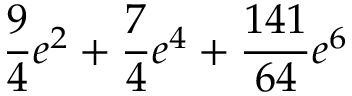Convert formula to latex. <formula><loc_0><loc_0><loc_500><loc_500>\frac { 9 } { 4 } e ^ { 2 } + \frac { 7 } { 4 } e ^ { 4 } + \frac { 1 4 1 } { 6 4 } e ^ { 6 }</formula> 